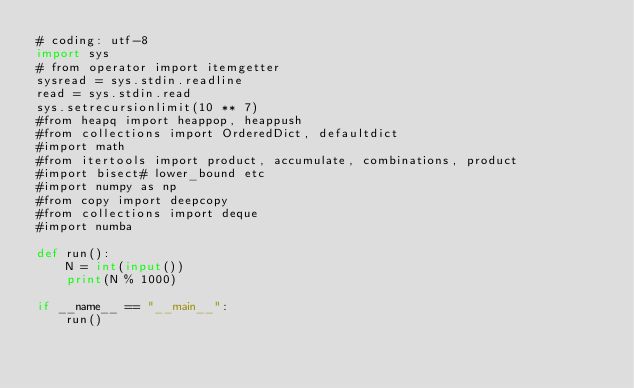Convert code to text. <code><loc_0><loc_0><loc_500><loc_500><_Python_># coding: utf-8
import sys
# from operator import itemgetter
sysread = sys.stdin.readline
read = sys.stdin.read
sys.setrecursionlimit(10 ** 7)
#from heapq import heappop, heappush
#from collections import OrderedDict, defaultdict
#import math
#from itertools import product, accumulate, combinations, product
#import bisect# lower_bound etc
#import numpy as np
#from copy import deepcopy
#from collections import deque
#import numba

def run():
    N = int(input())
    print(N % 1000)

if __name__ == "__main__":
    run()</code> 